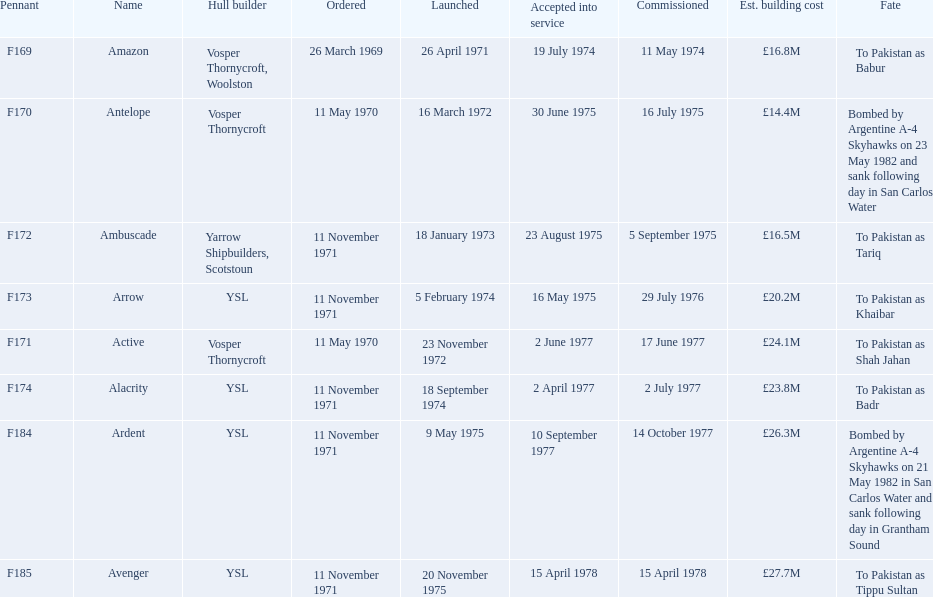Which type 21 frigate ships were to be built by ysl in the 1970s? Arrow, Alacrity, Ardent, Avenger. Of these ships, which one had the highest estimated building cost? Avenger. 